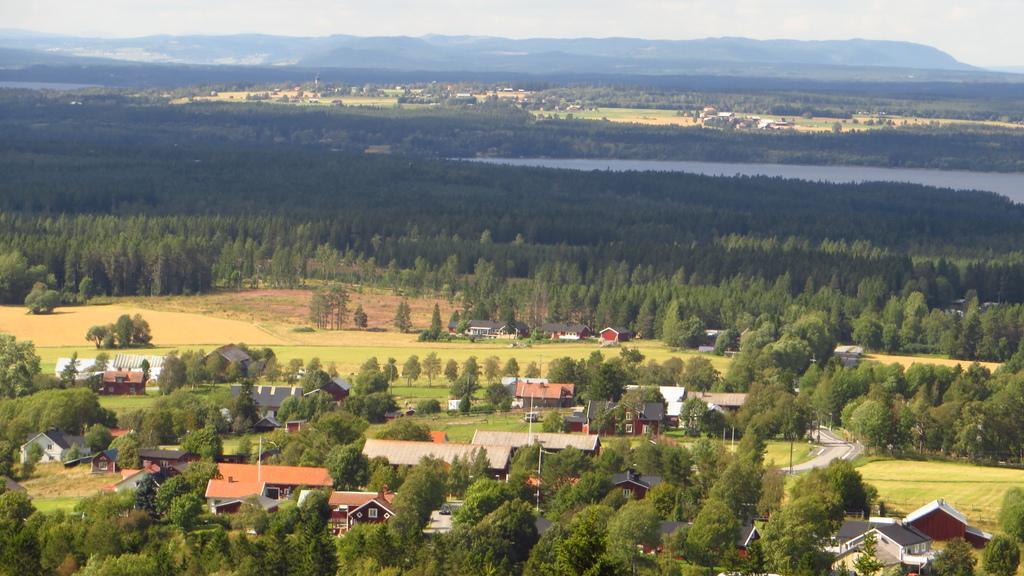Can you describe this image briefly? In this image I can see many trees and the houses. In the background I can see the water, few more trees, houses, mountains and the sky. 